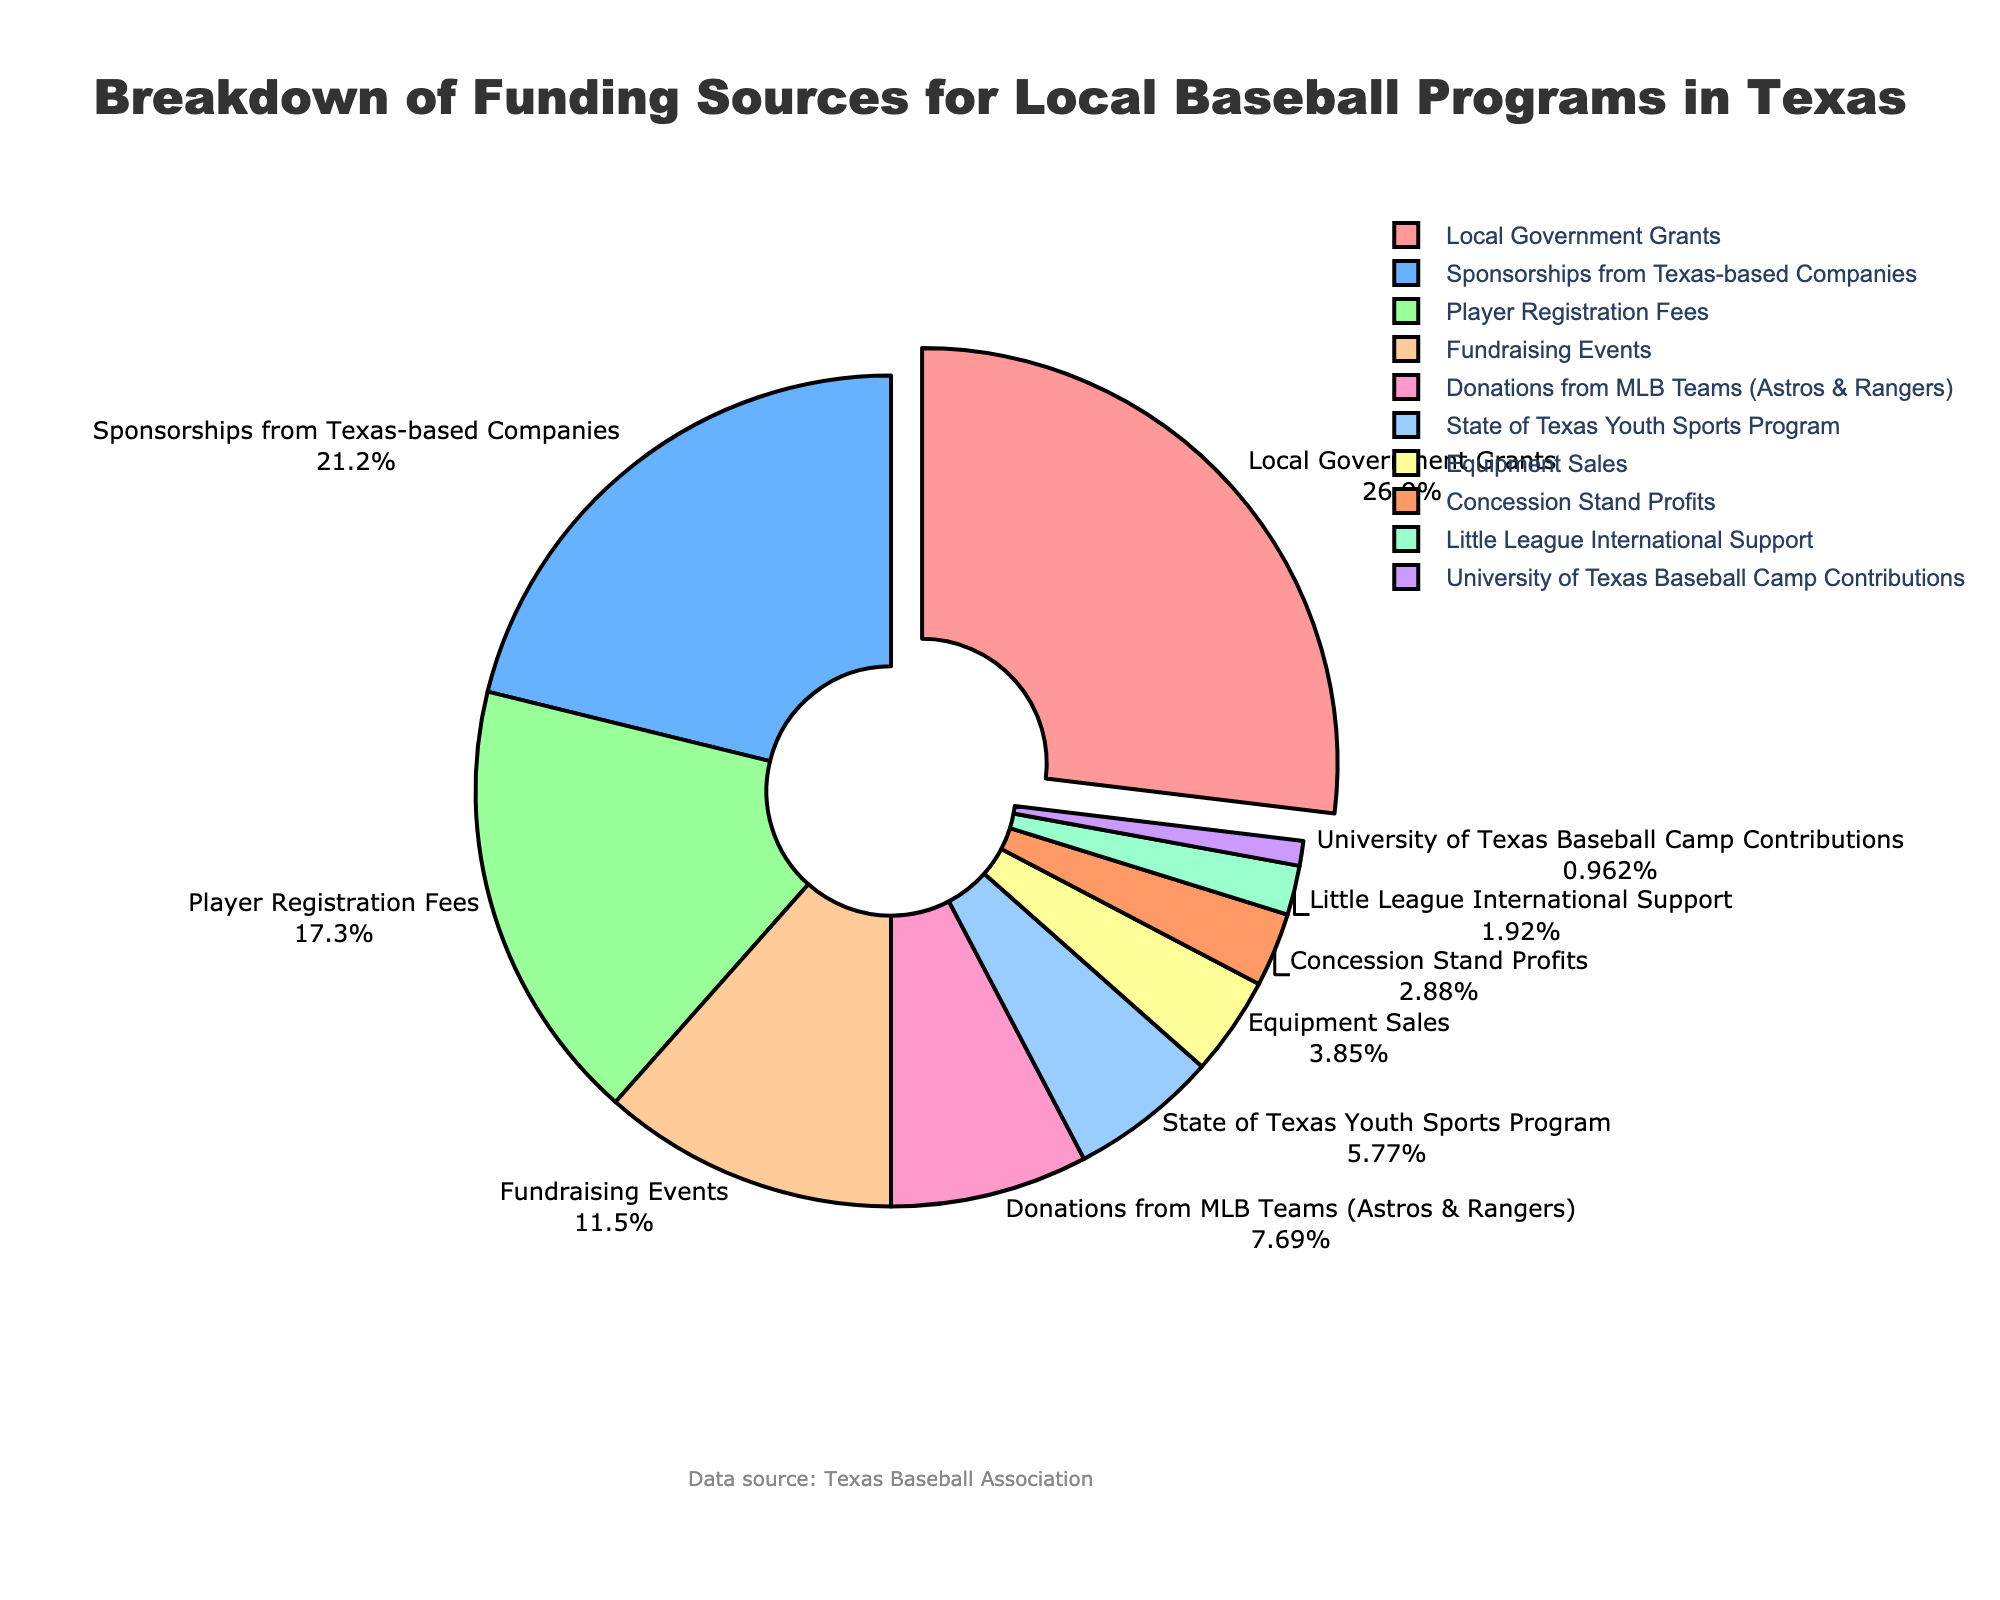Which funding source contributes the highest percentage? The caption indicating the breakdown of funding sources shows that the largest slice is labeled as "Local Government Grants" with 28%.
Answer: Local Government Grants Which funding source contributes the least percentage? The smallest slice in the chart is labeled as "University of Texas Baseball Camp Contributions" with 1%.
Answer: University of Texas Baseball Camp Contributions How much greater is the contribution from Sponsorships than from University of Texas Baseball Camp Contributions? Sponsorships from Texas-based Companies account for 22%, while University of Texas Baseball Camp Contributions account for 1%. The difference is 22% - 1% = 21%.
Answer: 21% What is the combined percentage of Player Registration Fees and Fundraising Events? Player Registration Fees contribute 18%, and Fundraising Events contribute 12%. Their combined contribution is 18% + 12% = 30%.
Answer: 30% Which funding sources have a combined total of less than 10%? Evaluating the smaller slices, Equipment Sales (4%), Concession Stand Profits (3%), Little League International Support (2%), and University of Texas Baseball Camp Contributions (1%) together sum up to 4% + 3% + 2% + 1% = 10%. Since each component is less than 10%, they individually qualify.
Answer: Equipment Sales, Concession Stand Profits, Little League International Support, University of Texas Baseball Camp Contributions How much more does the State of Texas Youth Sports Program contribute compared to Little League International Support? The State of Texas Youth Sports Program accounts for 6%, and Little League International Support accounts for 2%. The difference is 6% - 2% = 4%.
Answer: 4% What funding sources contribute equally to the local baseball programs? Observing the pie chart, we see that both Donations from MLB Teams (8%) and State of Texas Youth Sports Program (6%) are unique and do not share equality with another single source. Upon closer inspection, there's no exact equality between sources.
Answer: None Is the percentage contribution of Player Registration Fees greater than that of Fundraising Events? Player Registration Fees contribute 18%, while Fundraising Events contribute 12%. Since 18% is greater than 12%, the answer is yes.
Answer: Yes Which funding source is represented by the green slice in the pie chart? The green slice in the pie chart represents "Player Registration Fees." This is interpreted based on the typical color scheme used in the chart.
Answer: Player Registration Fees 